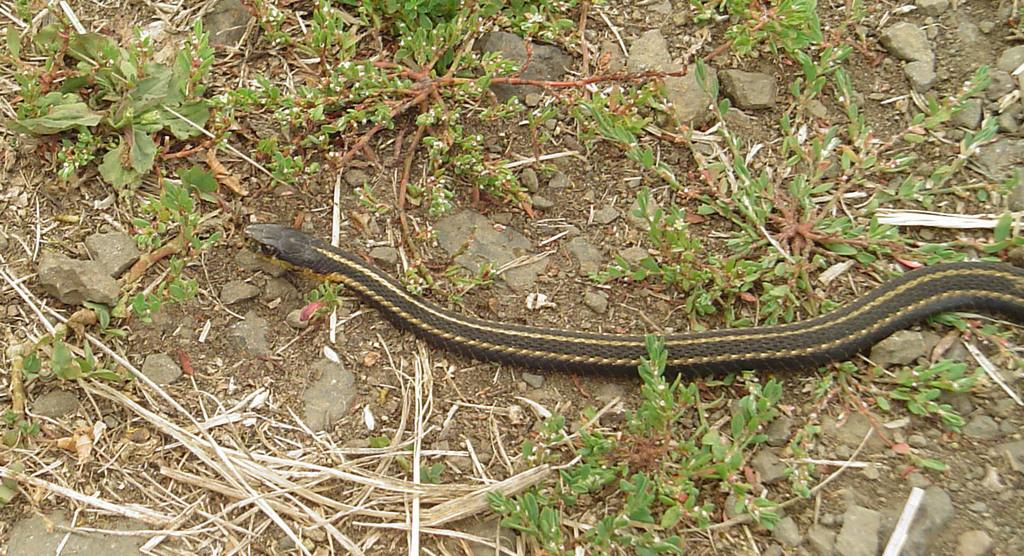What type of animal can be seen in the image? There is a snake in the image. What color is the snake? The snake is black in color. What type of vegetation is present in the image? There are small plants in the image. What is the ground made of in the image? Dry grass and stones are present at the bottom of the image. What type of hammer is the snake using to break the rocks in the image? There is no hammer present in the image, and the snake is not shown using any tool to break the rocks. 